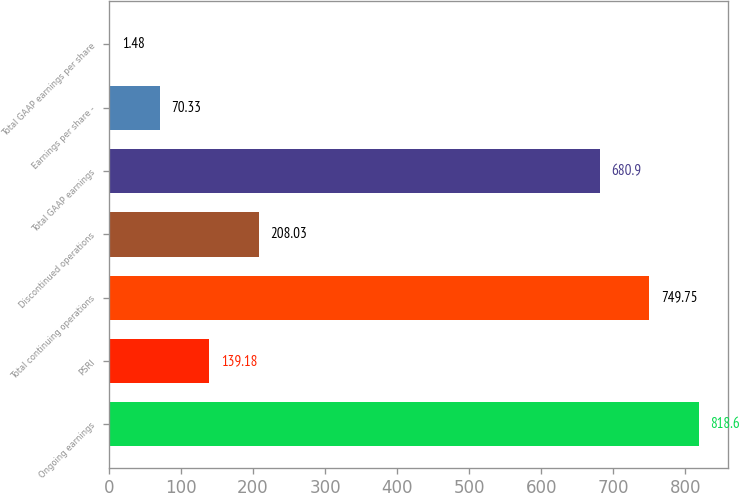Convert chart to OTSL. <chart><loc_0><loc_0><loc_500><loc_500><bar_chart><fcel>Ongoing earnings<fcel>PSRI<fcel>Total continuing operations<fcel>Discontinued operations<fcel>Total GAAP earnings<fcel>Earnings per share -<fcel>Total GAAP earnings per share<nl><fcel>818.6<fcel>139.18<fcel>749.75<fcel>208.03<fcel>680.9<fcel>70.33<fcel>1.48<nl></chart> 